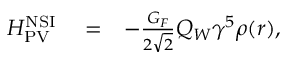<formula> <loc_0><loc_0><loc_500><loc_500>\begin{array} { r l r } { H _ { P V } ^ { N S I } } & = } & { - \frac { G _ { F } } { 2 \sqrt { 2 } } Q _ { W } \gamma ^ { 5 } \rho ( r ) , } \end{array}</formula> 